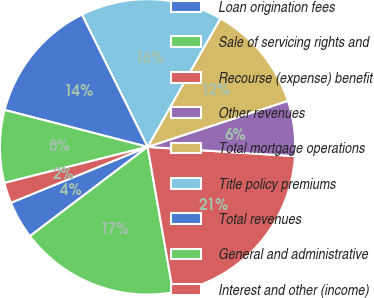<chart> <loc_0><loc_0><loc_500><loc_500><pie_chart><fcel>Loan origination fees<fcel>Sale of servicing rights and<fcel>Recourse (expense) benefit<fcel>Other revenues<fcel>Total mortgage operations<fcel>Title policy premiums<fcel>Total revenues<fcel>General and administrative<fcel>Interest and other (income)<nl><fcel>4.15%<fcel>17.44%<fcel>21.24%<fcel>6.05%<fcel>11.74%<fcel>15.54%<fcel>13.64%<fcel>7.95%<fcel>2.25%<nl></chart> 